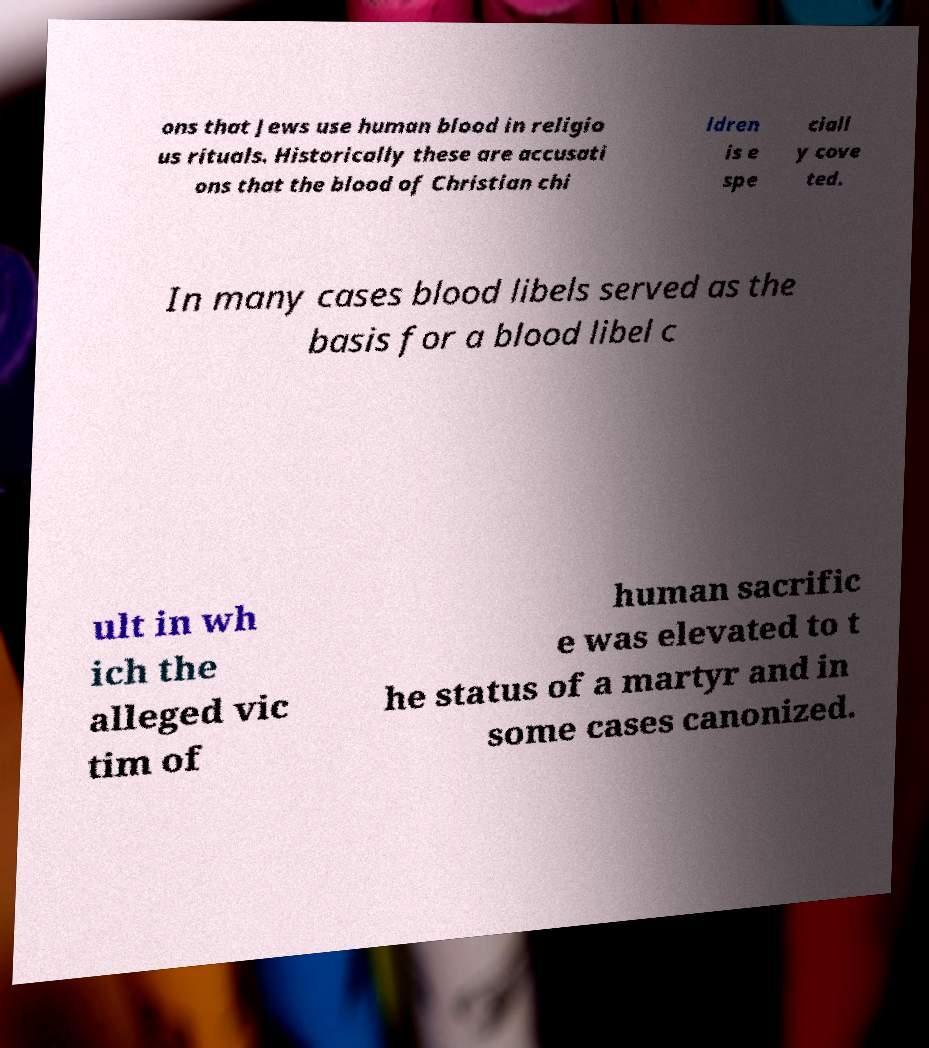Please identify and transcribe the text found in this image. ons that Jews use human blood in religio us rituals. Historically these are accusati ons that the blood of Christian chi ldren is e spe ciall y cove ted. In many cases blood libels served as the basis for a blood libel c ult in wh ich the alleged vic tim of human sacrific e was elevated to t he status of a martyr and in some cases canonized. 